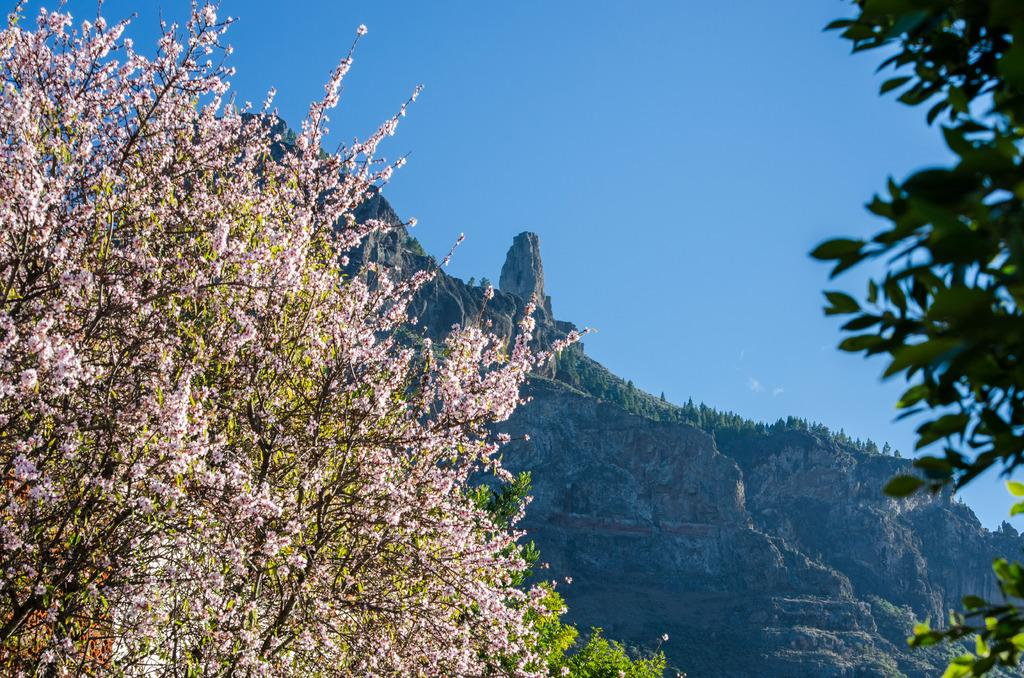What is present on both sides of the image? There are trees on both the left and right sides of the image. What can be seen in the background of the image? Some greenery is visible in the background of the image. What is the color of the sky in the image? The sky is blue in color. Can you see a nest in the trees on the left side of the image? There is no nest visible in the trees on the left side of the image. What effect does the ticket have on the image? There is no ticket present in the image, so it cannot have any effect on the image. 